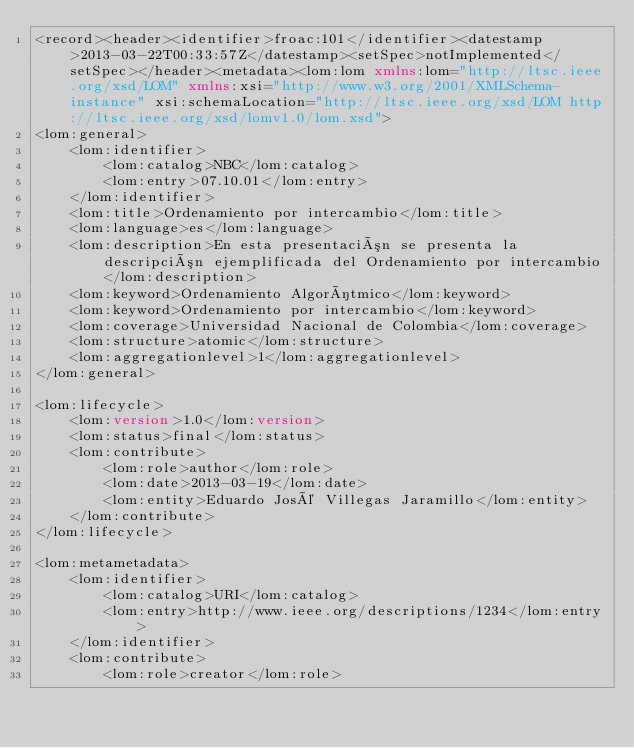Convert code to text. <code><loc_0><loc_0><loc_500><loc_500><_XML_><record><header><identifier>froac:101</identifier><datestamp>2013-03-22T00:33:57Z</datestamp><setSpec>notImplemented</setSpec></header><metadata><lom:lom xmlns:lom="http://ltsc.ieee.org/xsd/LOM" xmlns:xsi="http://www.w3.org/2001/XMLSchema-instance" xsi:schemaLocation="http://ltsc.ieee.org/xsd/LOM http://ltsc.ieee.org/xsd/lomv1.0/lom.xsd">
<lom:general>
	<lom:identifier>
		<lom:catalog>NBC</lom:catalog>
		<lom:entry>07.10.01</lom:entry>
	</lom:identifier>
	<lom:title>Ordenamiento por intercambio</lom:title>
	<lom:language>es</lom:language>
	<lom:description>En esta presentación se presenta la descripción ejemplificada del Ordenamiento por intercambio</lom:description>
	<lom:keyword>Ordenamiento Algorítmico</lom:keyword>
	<lom:keyword>Ordenamiento por intercambio</lom:keyword>
	<lom:coverage>Universidad Nacional de Colombia</lom:coverage>
	<lom:structure>atomic</lom:structure>
	<lom:aggregationlevel>1</lom:aggregationlevel>
</lom:general>

<lom:lifecycle>
	<lom:version>1.0</lom:version>
	<lom:status>final</lom:status>
	<lom:contribute>
		<lom:role>author</lom:role>
		<lom:date>2013-03-19</lom:date>
		<lom:entity>Eduardo José Villegas Jaramillo</lom:entity>
	</lom:contribute>
</lom:lifecycle>

<lom:metametadata>
	<lom:identifier>
		<lom:catalog>URI</lom:catalog>
		<lom:entry>http://www.ieee.org/descriptions/1234</lom:entry>
	</lom:identifier>
	<lom:contribute>
		<lom:role>creator</lom:role></code> 